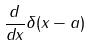Convert formula to latex. <formula><loc_0><loc_0><loc_500><loc_500>\frac { d } { d x } \delta ( x - a )</formula> 